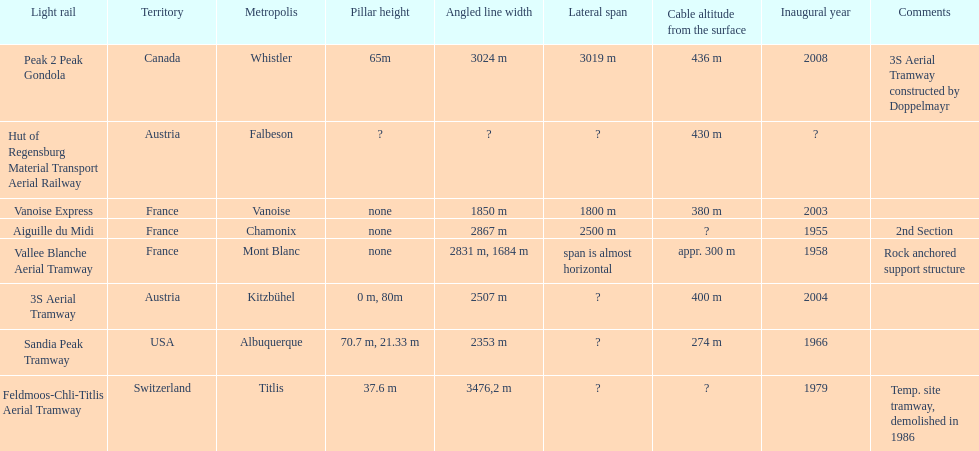How much longer is the peak 2 peak gondola than the 32 aerial tramway? 517. 